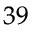Convert formula to latex. <formula><loc_0><loc_0><loc_500><loc_500>^ { 3 9 }</formula> 